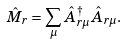Convert formula to latex. <formula><loc_0><loc_0><loc_500><loc_500>\hat { M } _ { r } = \sum _ { \mu } \hat { A } _ { r \mu } ^ { \dagger } \hat { A } _ { r \mu } .</formula> 